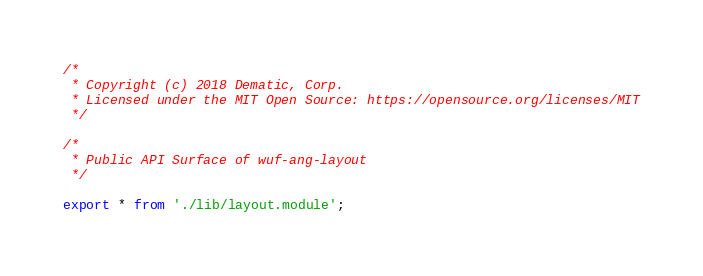<code> <loc_0><loc_0><loc_500><loc_500><_TypeScript_>/*
 * Copyright (c) 2018 Dematic, Corp.
 * Licensed under the MIT Open Source: https://opensource.org/licenses/MIT
 */

/*
 * Public API Surface of wuf-ang-layout
 */

export * from './lib/layout.module';
</code> 